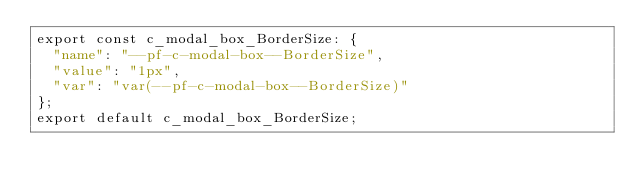<code> <loc_0><loc_0><loc_500><loc_500><_TypeScript_>export const c_modal_box_BorderSize: {
  "name": "--pf-c-modal-box--BorderSize",
  "value": "1px",
  "var": "var(--pf-c-modal-box--BorderSize)"
};
export default c_modal_box_BorderSize;</code> 